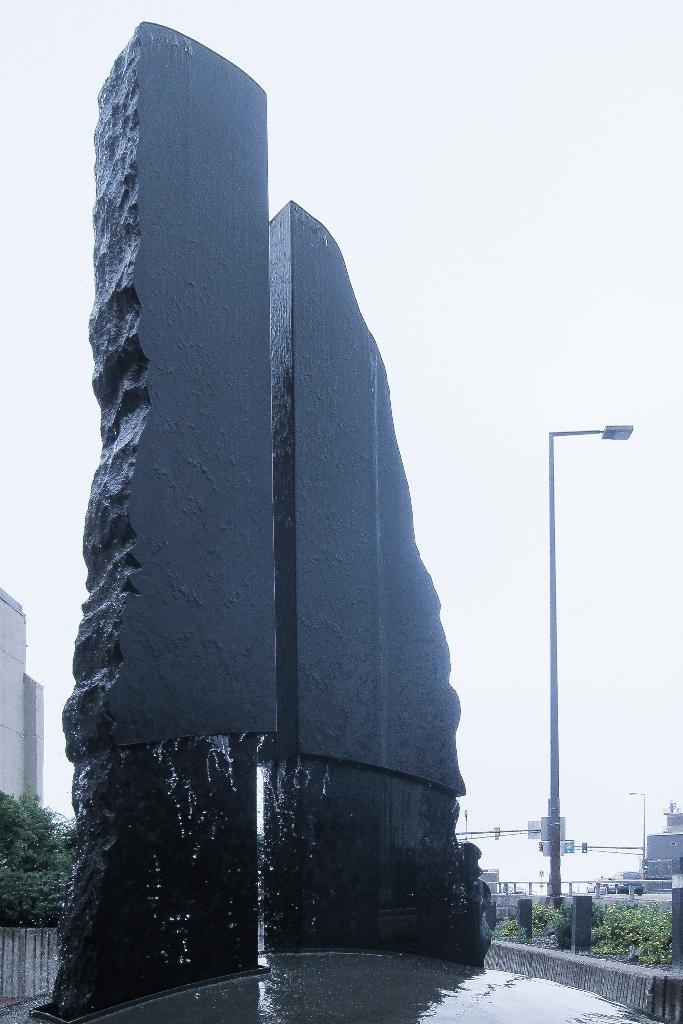What is the tallest object in the image? There is a tall rock in the image. What type of vegetation is on the right side of the image? There are plants on the right side of the image. What structure is on the right side of the image? There is a pole on the right side of the image. What type of man-made structure is on the left side of the image? There is a building on the left side of the image. What is visible at the top of the image? The sky is visible at the top of the image. How many degrees can be seen on the crib in the image? There is no crib present in the image. What type of footwear is visible on the right side of the image? There is no footwear visible in the image. 